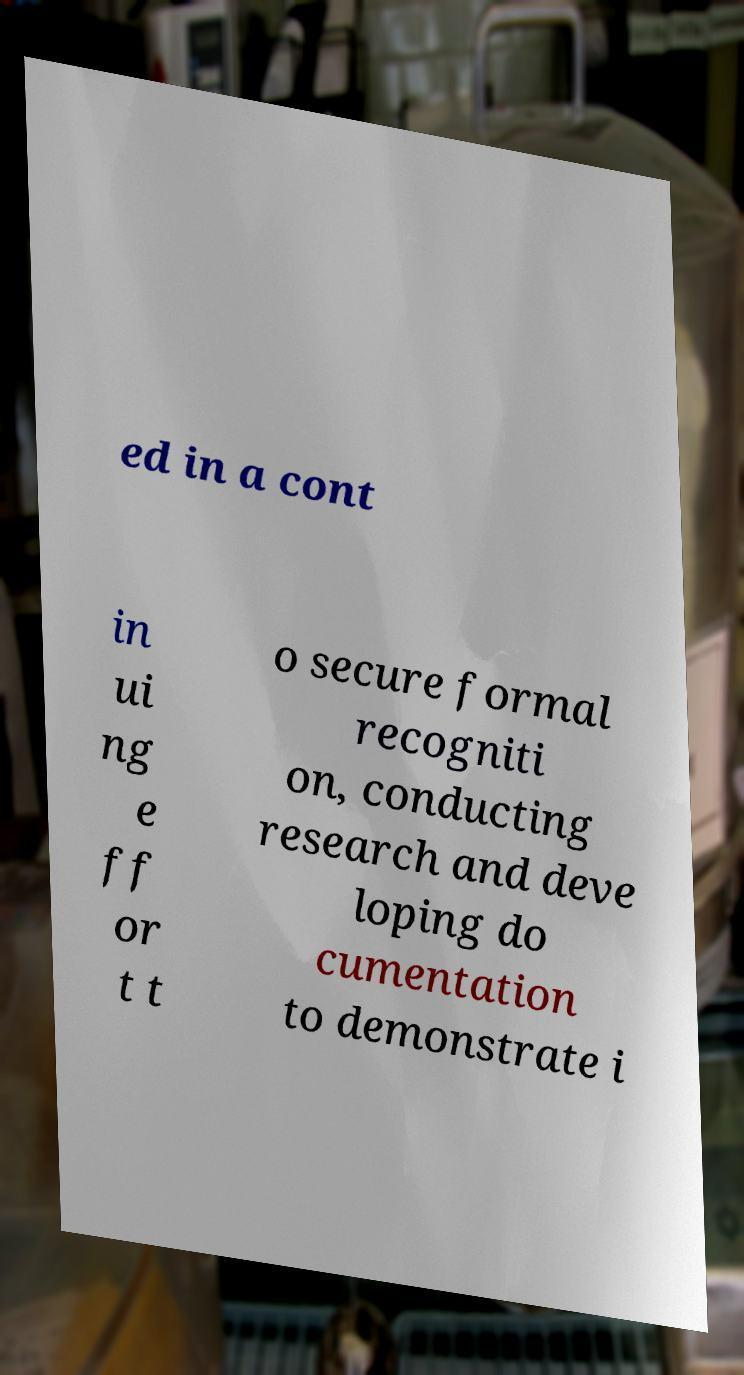Please identify and transcribe the text found in this image. ed in a cont in ui ng e ff or t t o secure formal recogniti on, conducting research and deve loping do cumentation to demonstrate i 